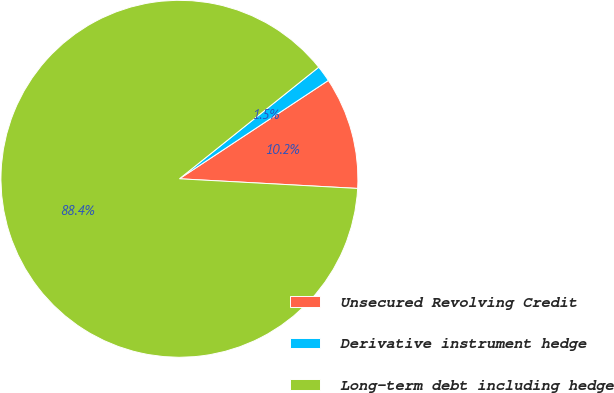Convert chart. <chart><loc_0><loc_0><loc_500><loc_500><pie_chart><fcel>Unsecured Revolving Credit<fcel>Derivative instrument hedge<fcel>Long-term debt including hedge<nl><fcel>10.15%<fcel>1.46%<fcel>88.38%<nl></chart> 